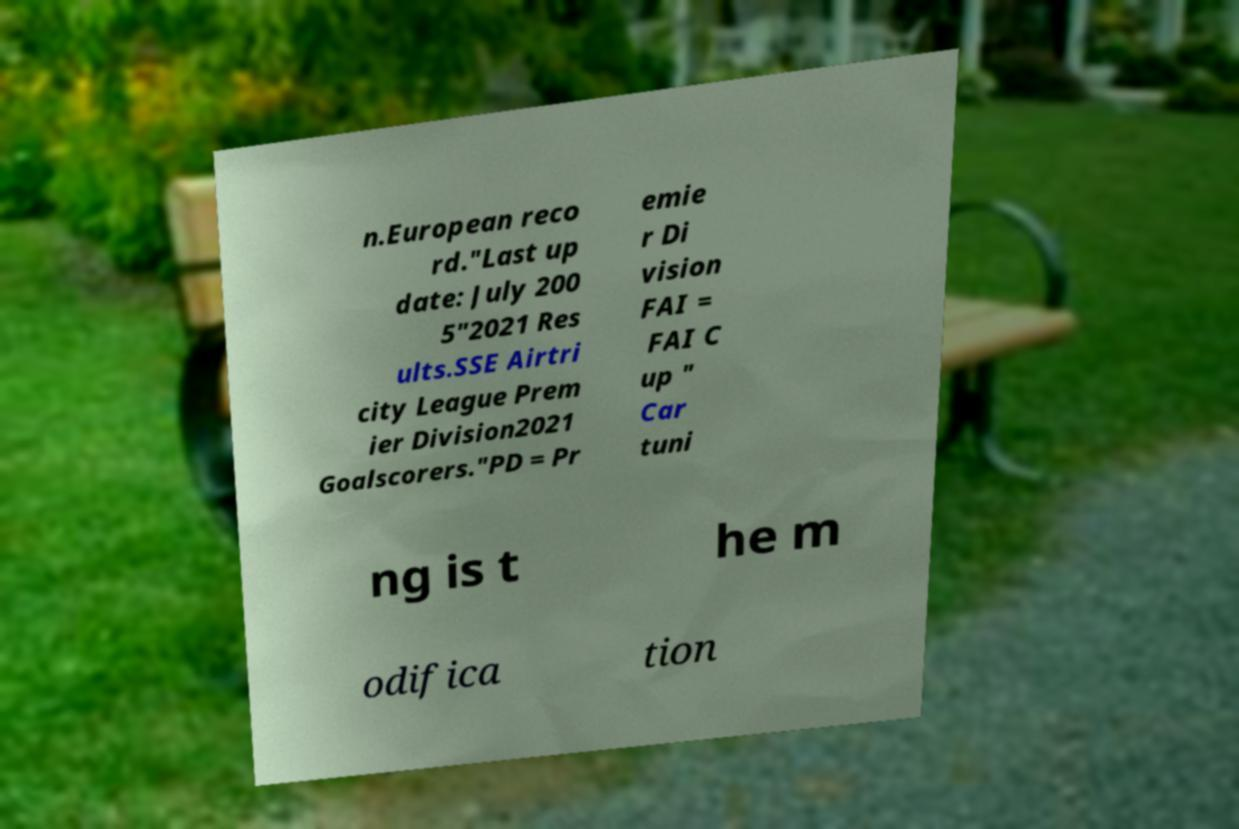Could you extract and type out the text from this image? n.European reco rd."Last up date: July 200 5"2021 Res ults.SSE Airtri city League Prem ier Division2021 Goalscorers."PD = Pr emie r Di vision FAI = FAI C up " Car tuni ng is t he m odifica tion 